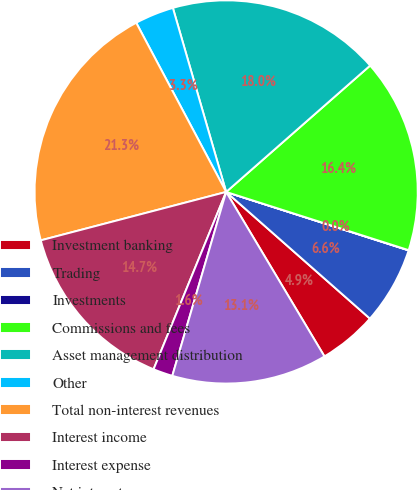Convert chart. <chart><loc_0><loc_0><loc_500><loc_500><pie_chart><fcel>Investment banking<fcel>Trading<fcel>Investments<fcel>Commissions and fees<fcel>Asset management distribution<fcel>Other<fcel>Total non-interest revenues<fcel>Interest income<fcel>Interest expense<fcel>Net interest<nl><fcel>4.93%<fcel>6.56%<fcel>0.02%<fcel>16.38%<fcel>18.02%<fcel>3.29%<fcel>21.29%<fcel>14.75%<fcel>1.65%<fcel>13.11%<nl></chart> 